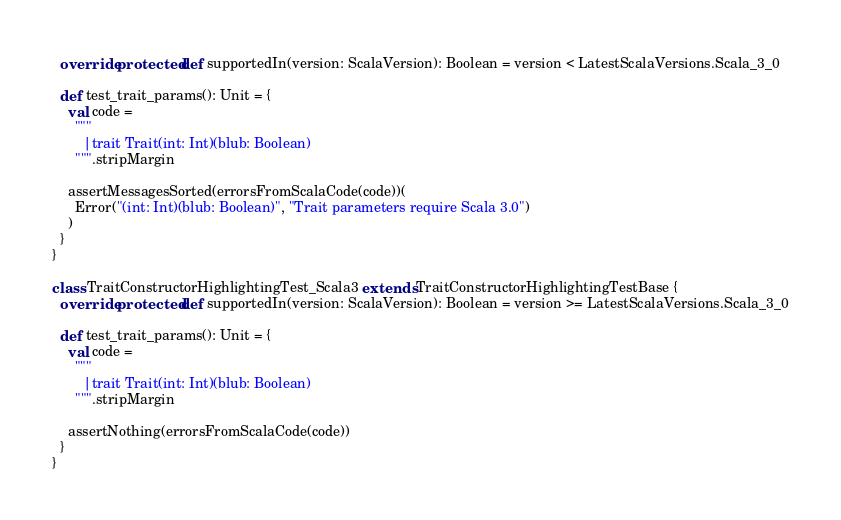Convert code to text. <code><loc_0><loc_0><loc_500><loc_500><_Scala_>  override protected def supportedIn(version: ScalaVersion): Boolean = version < LatestScalaVersions.Scala_3_0

  def test_trait_params(): Unit = {
    val code =
      """
        |trait Trait(int: Int)(blub: Boolean)
      """.stripMargin

    assertMessagesSorted(errorsFromScalaCode(code))(
      Error("(int: Int)(blub: Boolean)", "Trait parameters require Scala 3.0")
    )
  }
}

class TraitConstructorHighlightingTest_Scala3 extends TraitConstructorHighlightingTestBase {
  override protected def supportedIn(version: ScalaVersion): Boolean = version >= LatestScalaVersions.Scala_3_0

  def test_trait_params(): Unit = {
    val code =
      """
        |trait Trait(int: Int)(blub: Boolean)
      """.stripMargin

    assertNothing(errorsFromScalaCode(code))
  }
}

</code> 